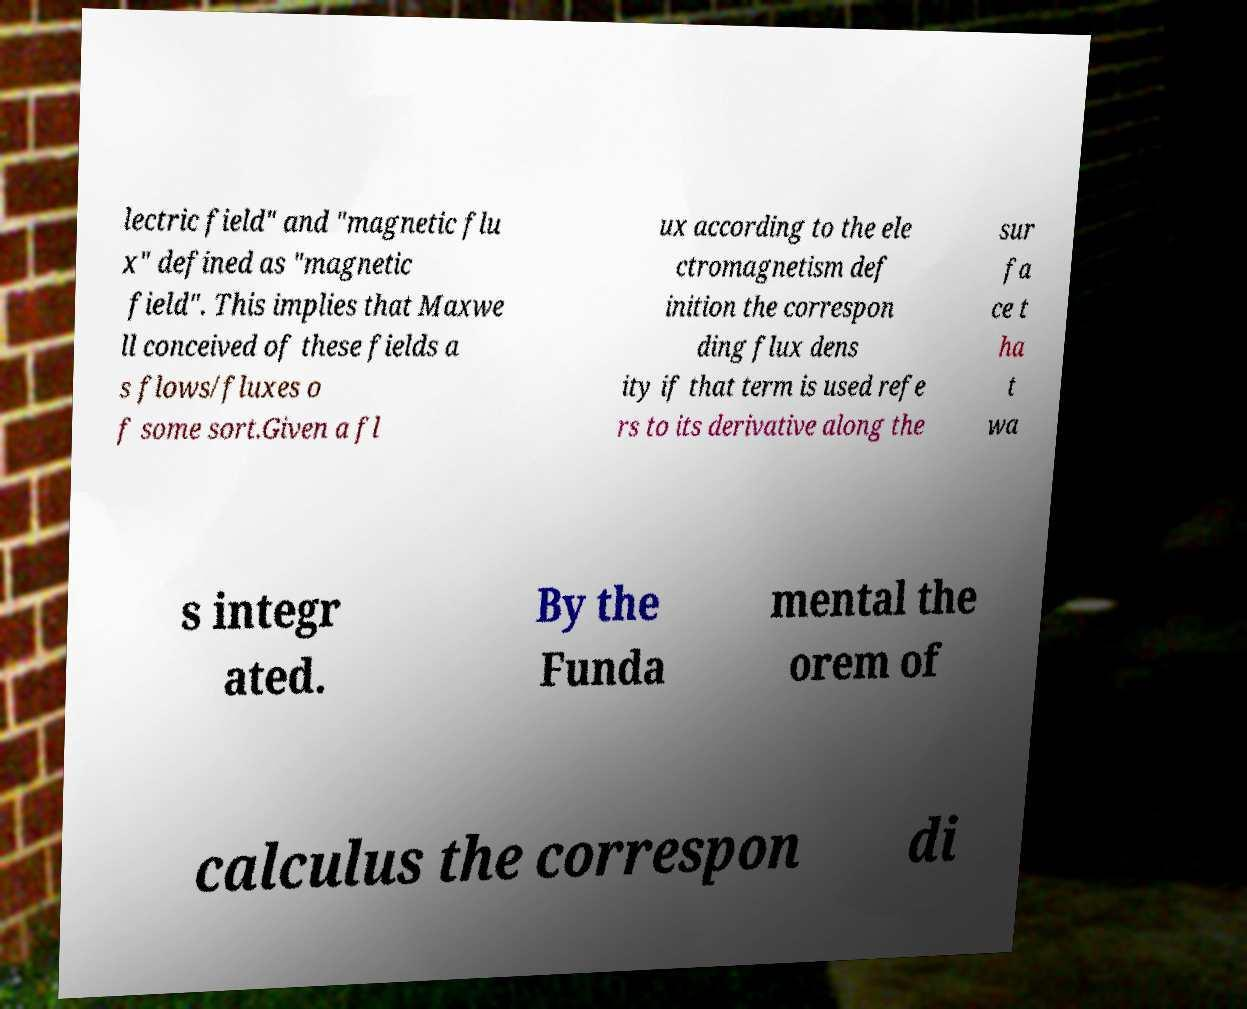Please identify and transcribe the text found in this image. lectric field" and "magnetic flu x" defined as "magnetic field". This implies that Maxwe ll conceived of these fields a s flows/fluxes o f some sort.Given a fl ux according to the ele ctromagnetism def inition the correspon ding flux dens ity if that term is used refe rs to its derivative along the sur fa ce t ha t wa s integr ated. By the Funda mental the orem of calculus the correspon di 